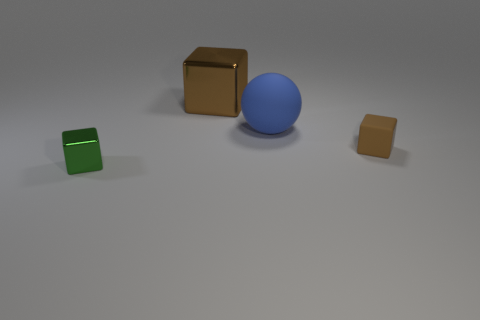Is the number of big rubber spheres greater than the number of brown blocks?
Provide a short and direct response. No. What is the material of the small green cube?
Provide a short and direct response. Metal. There is a shiny object that is right of the green block; is its size the same as the large matte thing?
Ensure brevity in your answer.  Yes. There is a brown block that is in front of the large rubber sphere; how big is it?
Your response must be concise. Small. How many tiny brown cubes are there?
Your response must be concise. 1. Does the tiny rubber block have the same color as the large metal cube?
Provide a succinct answer. Yes. There is a block that is both behind the green shiny block and in front of the large block; what is its color?
Provide a short and direct response. Brown. Are there any large blue objects in front of the tiny metallic cube?
Make the answer very short. No. What number of green metal cubes are behind the shiny thing behind the green shiny thing?
Provide a short and direct response. 0. What is the size of the brown block that is the same material as the blue object?
Give a very brief answer. Small. 